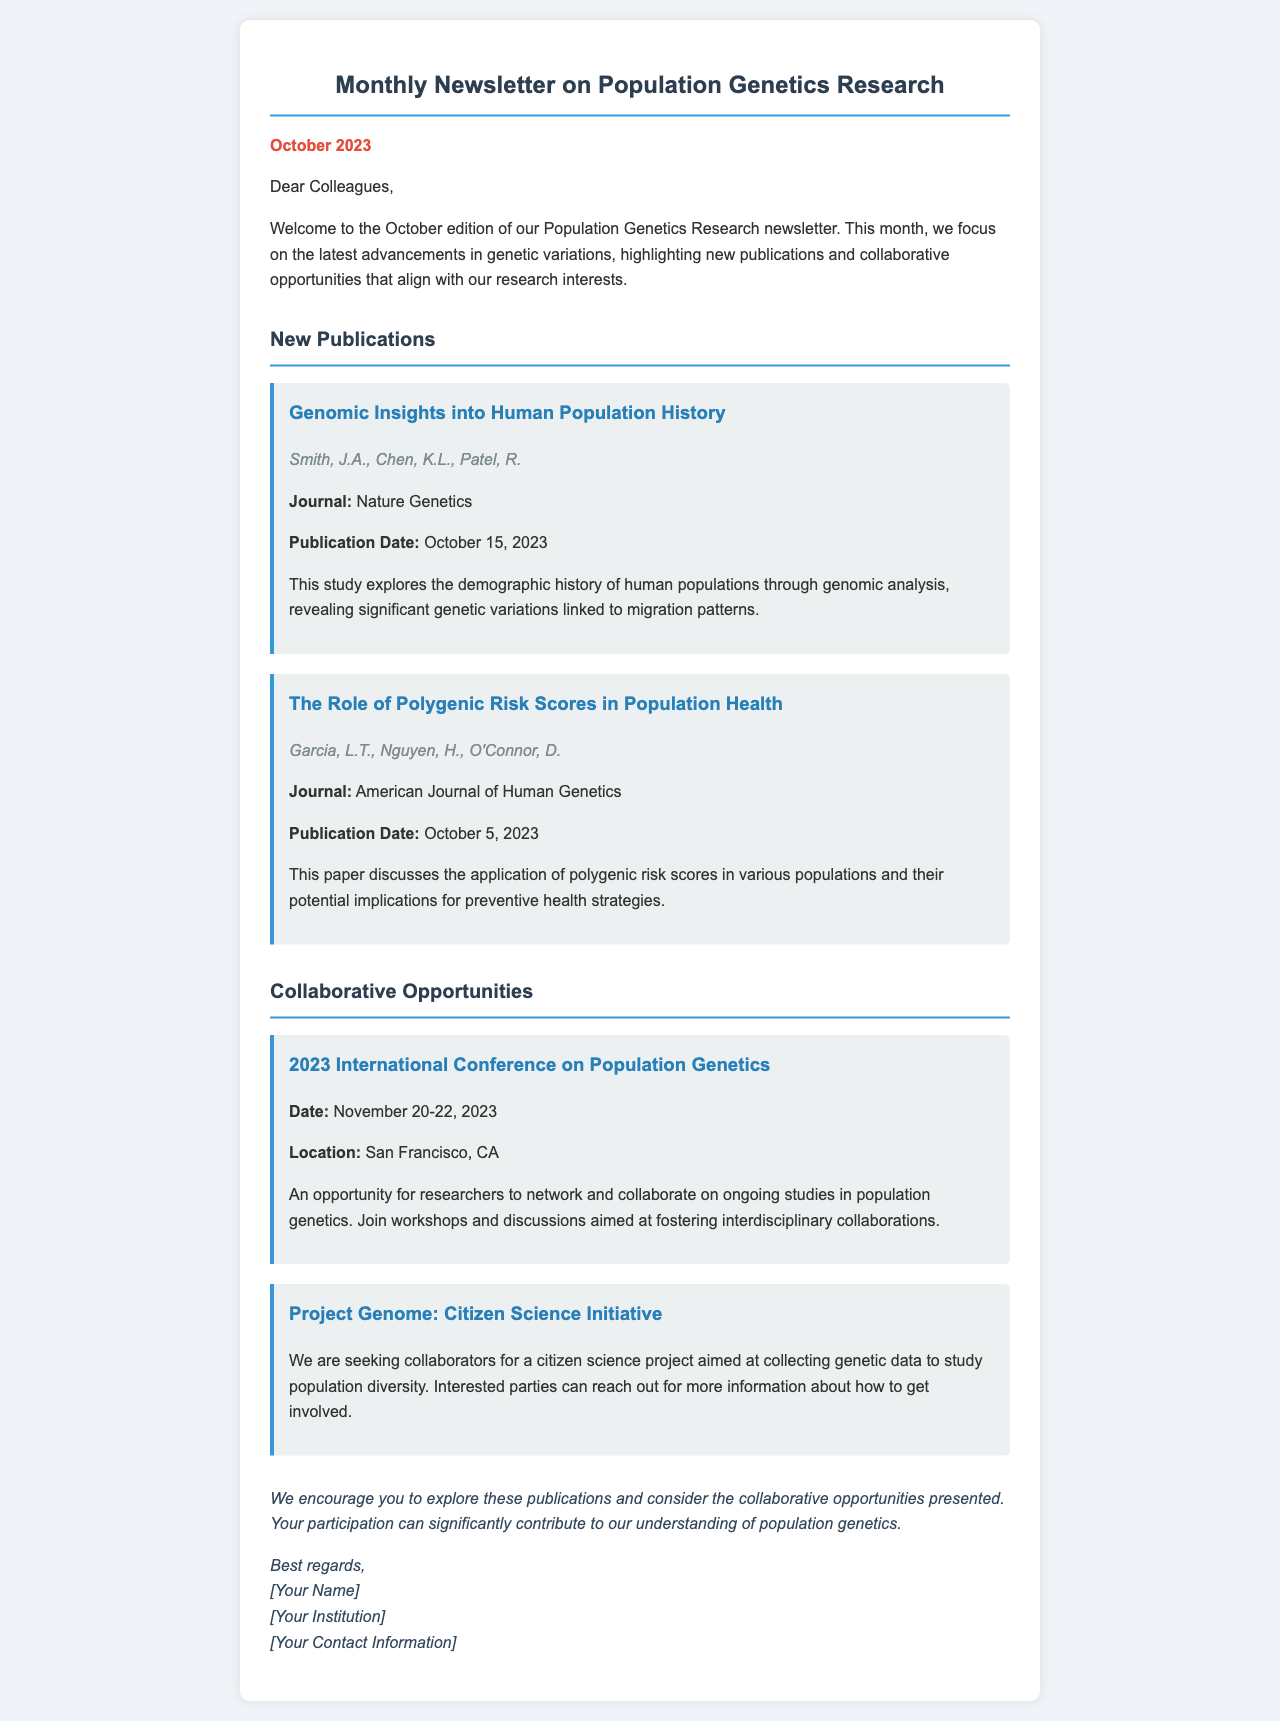What is the title of the first publication? The title of the first publication is listed under the "New Publications" section, which states "Genomic Insights into Human Population History."
Answer: Genomic Insights into Human Population History Who are the authors of the second publication? The authors of the second publication are provided in the details and are "Garcia, L.T., Nguyen, H., O'Connor, D."
Answer: Garcia, L.T., Nguyen, H., O'Connor, D What is the publication date of the first study? The document specifies the publication date of the first study as October 15, 2023, under the "New Publications" section.
Answer: October 15, 2023 What is the location of the International Conference on Population Genetics? The location is mentioned in the details of the collaborative opportunities section, stating "San Francisco, CA."
Answer: San Francisco, CA What type of initiative is "Project Genome"? The type of initiative is described as a "Citizen Science Initiative" in the collaborative opportunities section of the document.
Answer: Citizen Science Initiative What do the workshops and discussions at the conference aim to foster? The workshops and discussions are stated to be aimed at fostering "interdisciplinary collaborations."
Answer: interdisciplinary collaborations When is the "2023 International Conference on Population Genetics" scheduled? The schedule is given clearly in the collaborative opportunities section, indicating it will take place from November 20-22, 2023.
Answer: November 20-22, 2023 What is encouraged regarding the new publications? The document encourages readers to "explore these publications" as part of the closing remarks.
Answer: explore these publications 